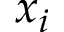Convert formula to latex. <formula><loc_0><loc_0><loc_500><loc_500>x _ { i }</formula> 